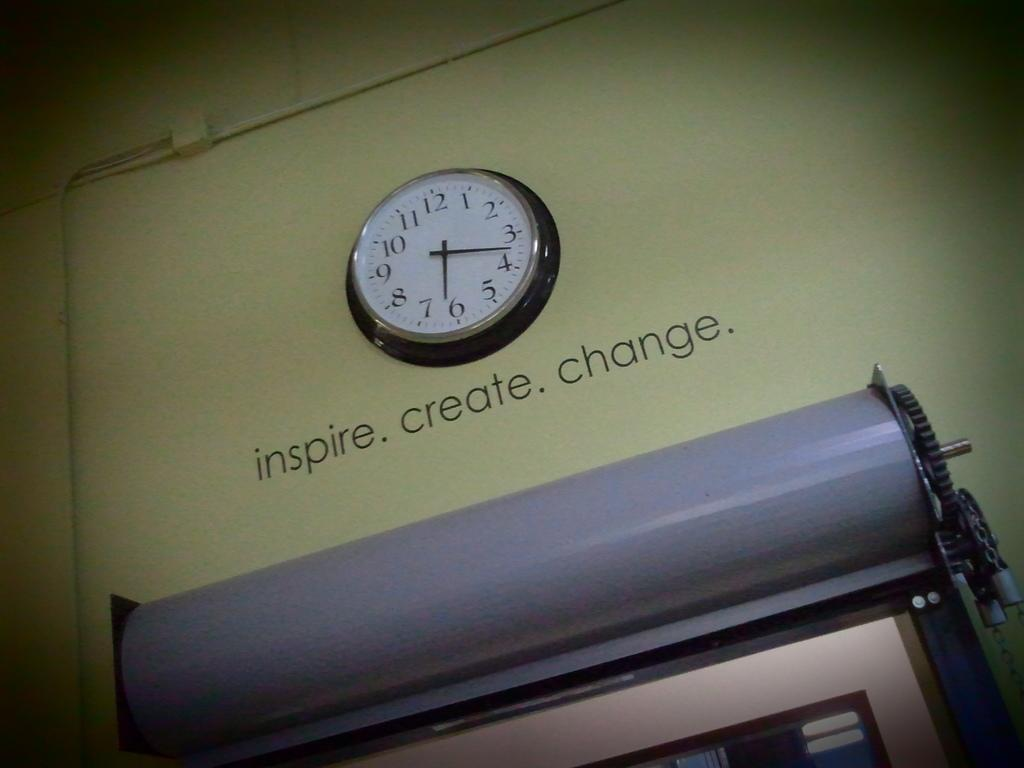<image>
Describe the image concisely. The words inspire, create and change appear on a wall below a clock. 